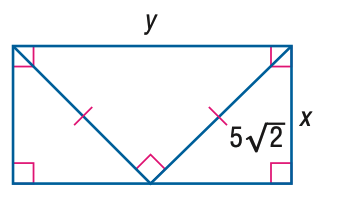Answer the mathemtical geometry problem and directly provide the correct option letter.
Question: Find x.
Choices: A: \frac { 5 } { 2 } \sqrt { 2 } B: 5 C: \frac { 5 } { 2 } \sqrt { 6 } D: 10 B 